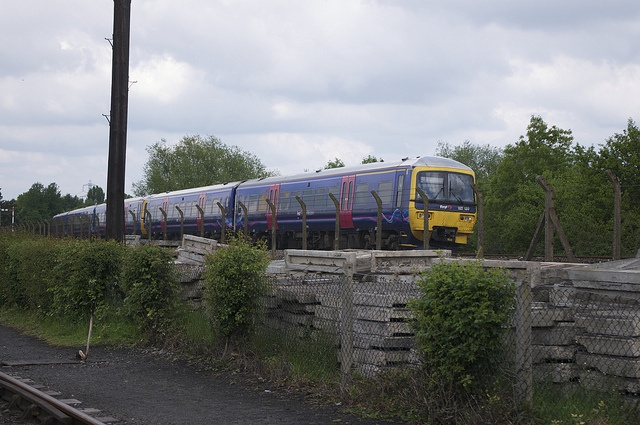Describe the objects in this image and their specific colors. I can see a train in lightgray, black, gray, and darkgray tones in this image. 